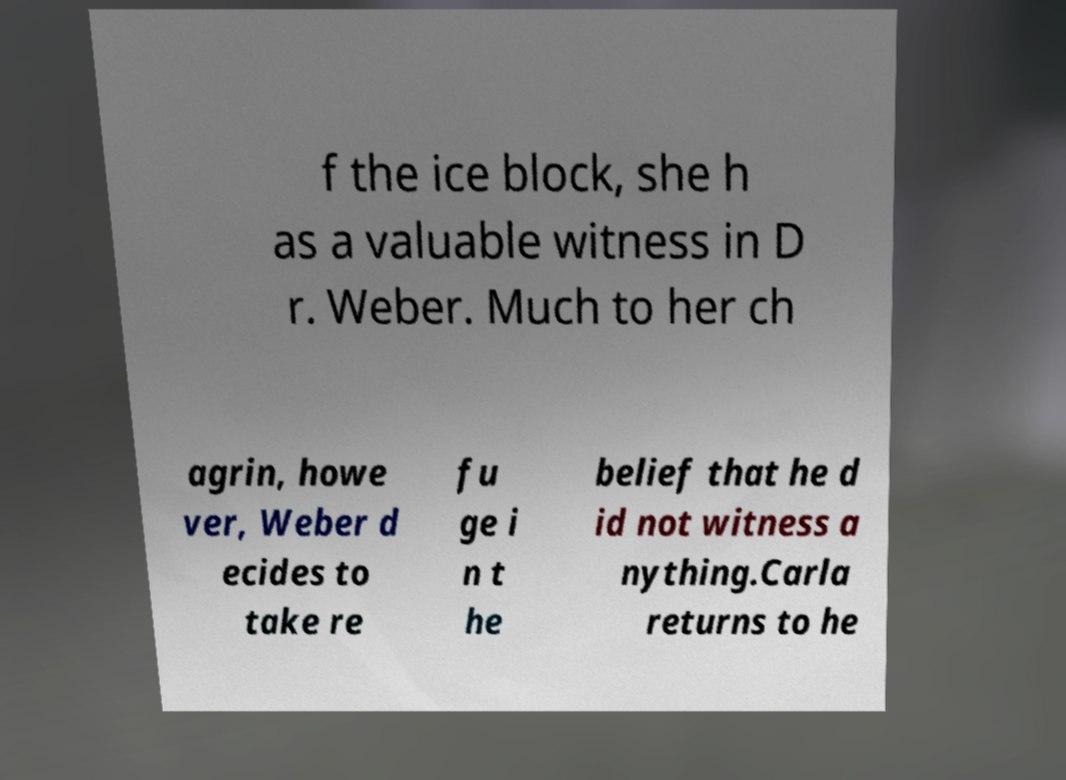Please identify and transcribe the text found in this image. f the ice block, she h as a valuable witness in D r. Weber. Much to her ch agrin, howe ver, Weber d ecides to take re fu ge i n t he belief that he d id not witness a nything.Carla returns to he 